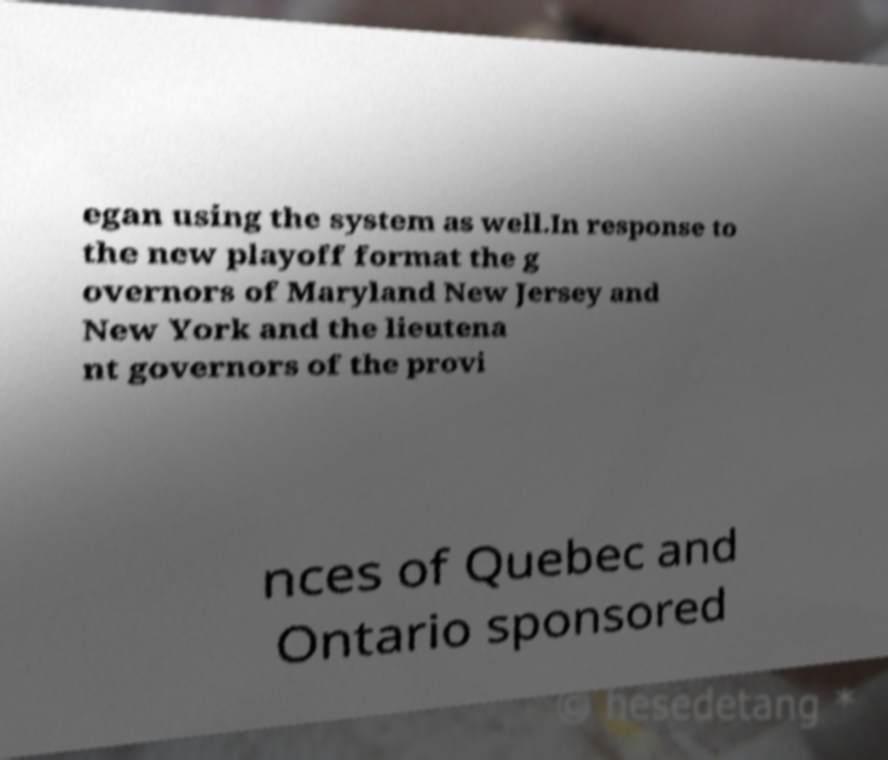Please read and relay the text visible in this image. What does it say? egan using the system as well.In response to the new playoff format the g overnors of Maryland New Jersey and New York and the lieutena nt governors of the provi nces of Quebec and Ontario sponsored 